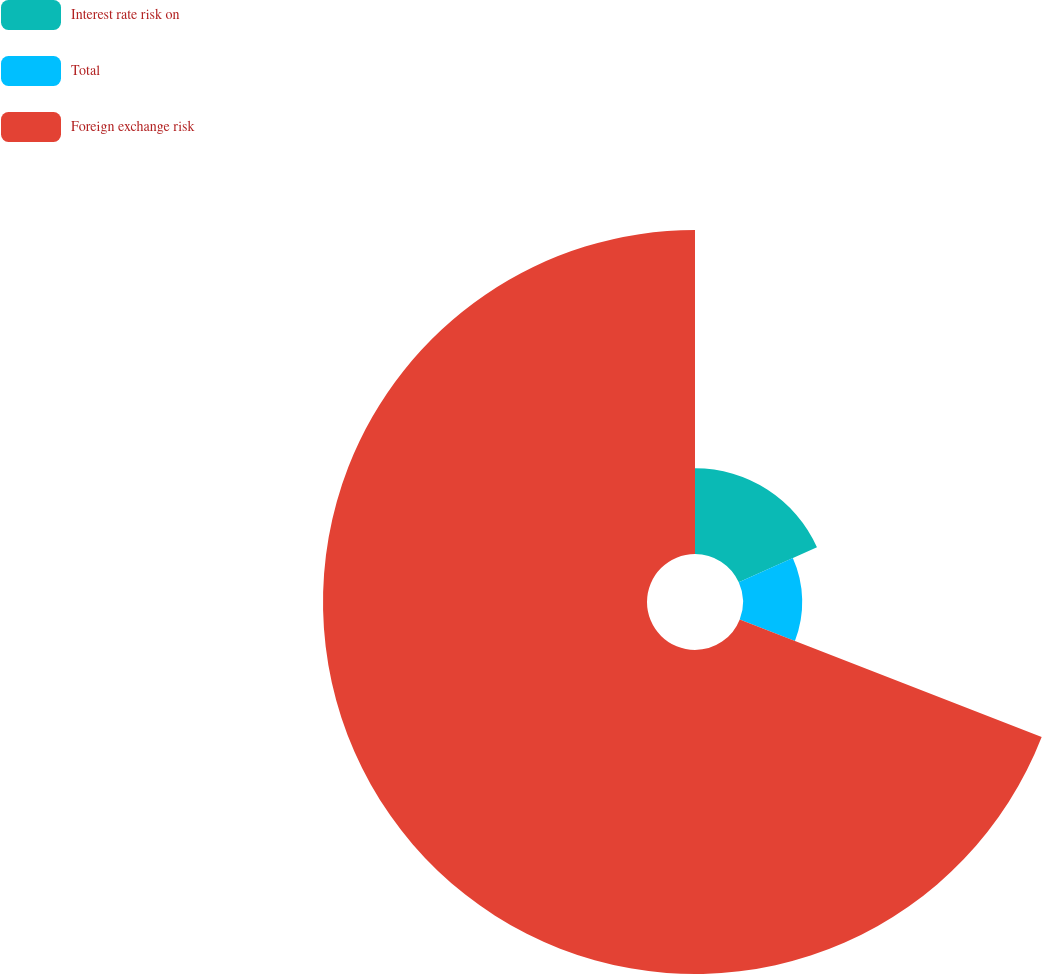Convert chart. <chart><loc_0><loc_0><loc_500><loc_500><pie_chart><fcel>Interest rate risk on<fcel>Total<fcel>Foreign exchange risk<nl><fcel>18.28%<fcel>12.63%<fcel>69.1%<nl></chart> 